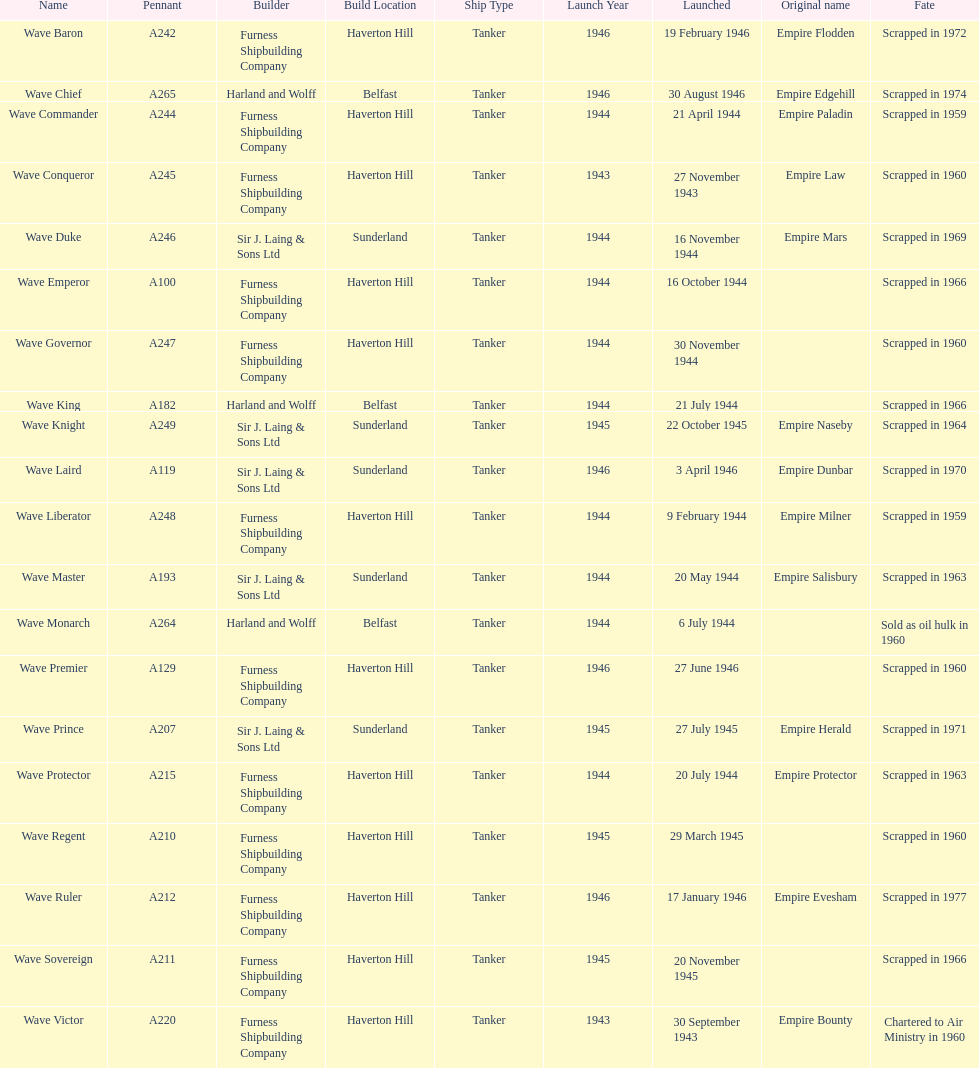Would you mind parsing the complete table? {'header': ['Name', 'Pennant', 'Builder', 'Build Location', 'Ship Type', 'Launch Year', 'Launched', 'Original name', 'Fate'], 'rows': [['Wave Baron', 'A242', 'Furness Shipbuilding Company', 'Haverton Hill', 'Tanker', '1946', '19 February 1946', 'Empire Flodden', 'Scrapped in 1972'], ['Wave Chief', 'A265', 'Harland and Wolff', 'Belfast', 'Tanker', '1946', '30 August 1946', 'Empire Edgehill', 'Scrapped in 1974'], ['Wave Commander', 'A244', 'Furness Shipbuilding Company', 'Haverton Hill', 'Tanker', '1944', '21 April 1944', 'Empire Paladin', 'Scrapped in 1959'], ['Wave Conqueror', 'A245', 'Furness Shipbuilding Company', 'Haverton Hill', 'Tanker', '1943', '27 November 1943', 'Empire Law', 'Scrapped in 1960'], ['Wave Duke', 'A246', 'Sir J. Laing & Sons Ltd', 'Sunderland', 'Tanker', '1944', '16 November 1944', 'Empire Mars', 'Scrapped in 1969'], ['Wave Emperor', 'A100', 'Furness Shipbuilding Company', 'Haverton Hill', 'Tanker', '1944', '16 October 1944', '', 'Scrapped in 1966'], ['Wave Governor', 'A247', 'Furness Shipbuilding Company', 'Haverton Hill', 'Tanker', '1944', '30 November 1944', '', 'Scrapped in 1960'], ['Wave King', 'A182', 'Harland and Wolff', 'Belfast', 'Tanker', '1944', '21 July 1944', '', 'Scrapped in 1966'], ['Wave Knight', 'A249', 'Sir J. Laing & Sons Ltd', 'Sunderland', 'Tanker', '1945', '22 October 1945', 'Empire Naseby', 'Scrapped in 1964'], ['Wave Laird', 'A119', 'Sir J. Laing & Sons Ltd', 'Sunderland', 'Tanker', '1946', '3 April 1946', 'Empire Dunbar', 'Scrapped in 1970'], ['Wave Liberator', 'A248', 'Furness Shipbuilding Company', 'Haverton Hill', 'Tanker', '1944', '9 February 1944', 'Empire Milner', 'Scrapped in 1959'], ['Wave Master', 'A193', 'Sir J. Laing & Sons Ltd', 'Sunderland', 'Tanker', '1944', '20 May 1944', 'Empire Salisbury', 'Scrapped in 1963'], ['Wave Monarch', 'A264', 'Harland and Wolff', 'Belfast', 'Tanker', '1944', '6 July 1944', '', 'Sold as oil hulk in 1960'], ['Wave Premier', 'A129', 'Furness Shipbuilding Company', 'Haverton Hill', 'Tanker', '1946', '27 June 1946', '', 'Scrapped in 1960'], ['Wave Prince', 'A207', 'Sir J. Laing & Sons Ltd', 'Sunderland', 'Tanker', '1945', '27 July 1945', 'Empire Herald', 'Scrapped in 1971'], ['Wave Protector', 'A215', 'Furness Shipbuilding Company', 'Haverton Hill', 'Tanker', '1944', '20 July 1944', 'Empire Protector', 'Scrapped in 1963'], ['Wave Regent', 'A210', 'Furness Shipbuilding Company', 'Haverton Hill', 'Tanker', '1945', '29 March 1945', '', 'Scrapped in 1960'], ['Wave Ruler', 'A212', 'Furness Shipbuilding Company', 'Haverton Hill', 'Tanker', '1946', '17 January 1946', 'Empire Evesham', 'Scrapped in 1977'], ['Wave Sovereign', 'A211', 'Furness Shipbuilding Company', 'Haverton Hill', 'Tanker', '1945', '20 November 1945', '', 'Scrapped in 1966'], ['Wave Victor', 'A220', 'Furness Shipbuilding Company', 'Haverton Hill', 'Tanker', '1943', '30 September 1943', 'Empire Bounty', 'Chartered to Air Ministry in 1960']]} Name a builder with "and" in the name. Harland and Wolff. 